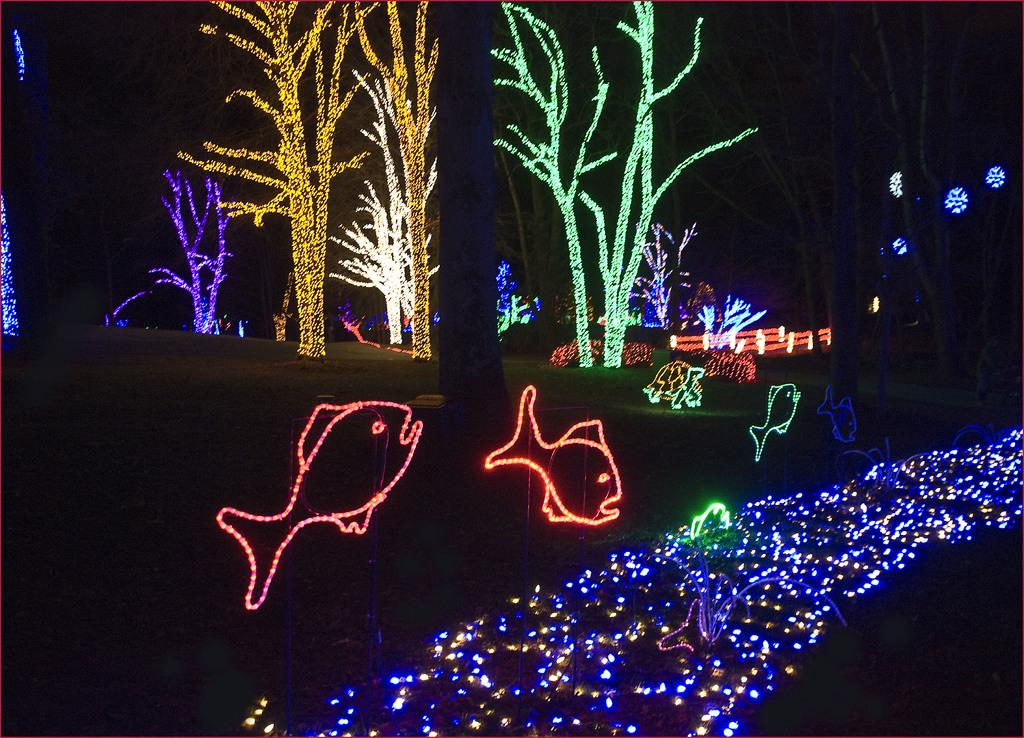What type of picture is the image? The image is a night vision picture. What can be seen in the distance in the image? Trees in the distance are decorated with lights. What else is decorated with lights in the image? Artificial fishes are decorated with lights. What color is the light in the foreground of the image? There is a blue light in the foreground. What type of action is the clam performing in the image? There is no clam present in the image, so no action can be observed. How does the ground appear in the image? The ground is not visible in the image, as it is a night vision picture focused on the decorated trees and fishes. 